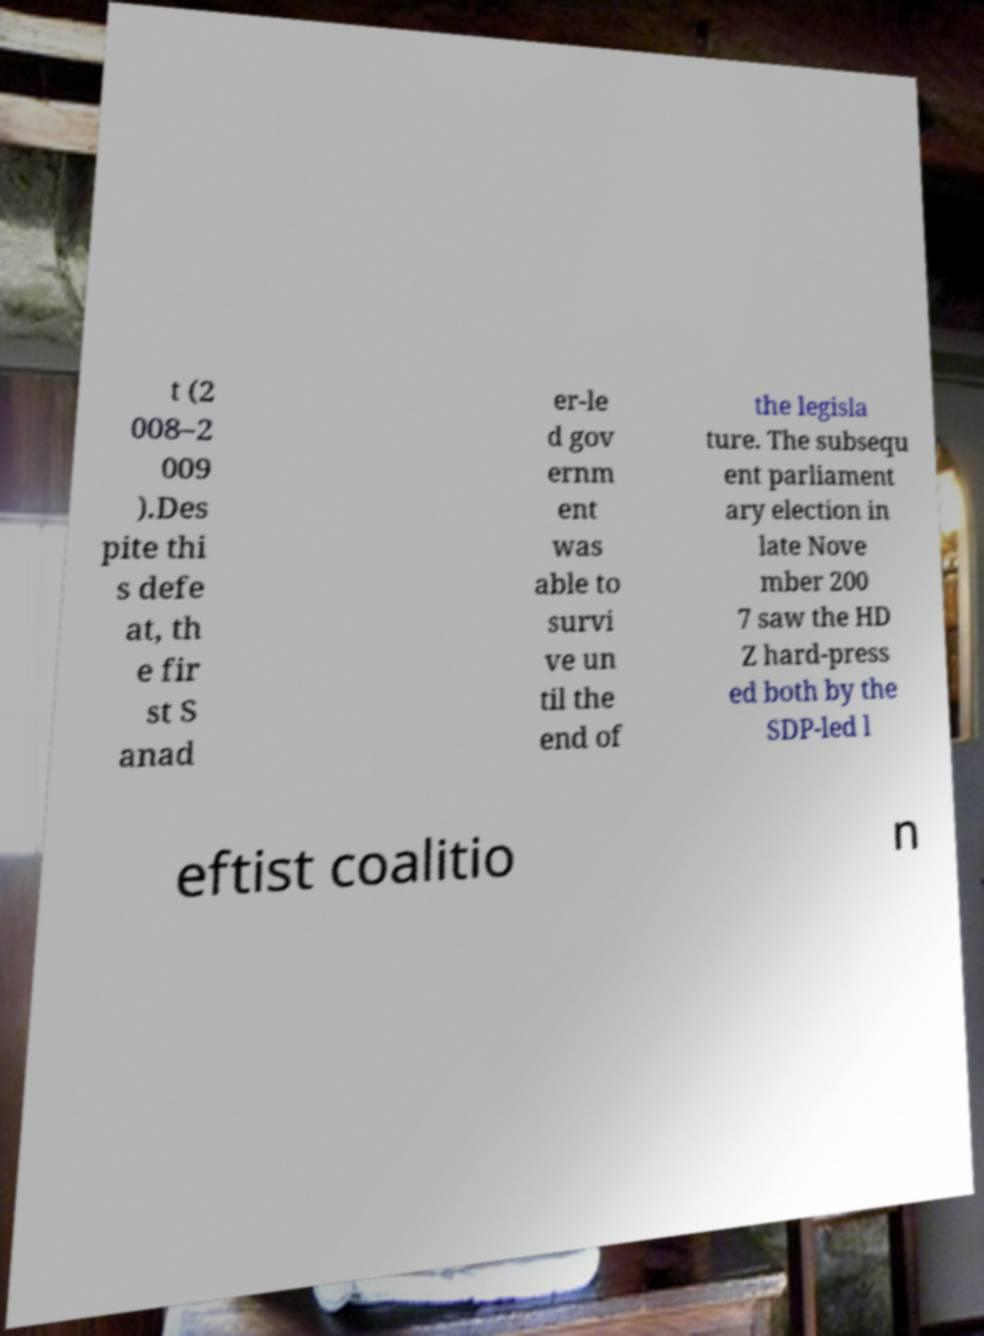Could you extract and type out the text from this image? t (2 008–2 009 ).Des pite thi s defe at, th e fir st S anad er-le d gov ernm ent was able to survi ve un til the end of the legisla ture. The subsequ ent parliament ary election in late Nove mber 200 7 saw the HD Z hard-press ed both by the SDP-led l eftist coalitio n 